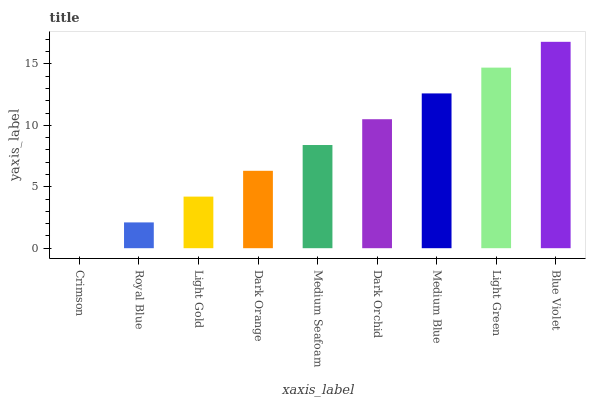Is Crimson the minimum?
Answer yes or no. Yes. Is Blue Violet the maximum?
Answer yes or no. Yes. Is Royal Blue the minimum?
Answer yes or no. No. Is Royal Blue the maximum?
Answer yes or no. No. Is Royal Blue greater than Crimson?
Answer yes or no. Yes. Is Crimson less than Royal Blue?
Answer yes or no. Yes. Is Crimson greater than Royal Blue?
Answer yes or no. No. Is Royal Blue less than Crimson?
Answer yes or no. No. Is Medium Seafoam the high median?
Answer yes or no. Yes. Is Medium Seafoam the low median?
Answer yes or no. Yes. Is Light Green the high median?
Answer yes or no. No. Is Royal Blue the low median?
Answer yes or no. No. 